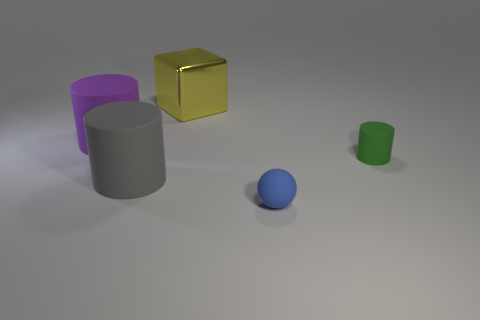Are there any other things that have the same material as the block?
Offer a terse response. No. Does the green matte thing have the same shape as the metal thing?
Your response must be concise. No. Does the cylinder that is right of the large yellow metallic block have the same size as the matte object that is on the left side of the gray matte thing?
Your answer should be very brief. No. How many things are tiny rubber things behind the small blue object or green matte cylinders?
Offer a terse response. 1. Are there fewer tiny blue objects than large matte spheres?
Provide a succinct answer. No. What is the shape of the thing that is in front of the large cylinder that is in front of the rubber cylinder to the right of the big metal object?
Give a very brief answer. Sphere. Are any brown spheres visible?
Give a very brief answer. No. There is a gray rubber cylinder; is it the same size as the blue object that is to the right of the purple cylinder?
Provide a short and direct response. No. There is a big cylinder to the right of the purple rubber cylinder; is there a blue sphere left of it?
Give a very brief answer. No. What is the object that is both on the right side of the big metallic thing and behind the blue ball made of?
Your answer should be compact. Rubber. 